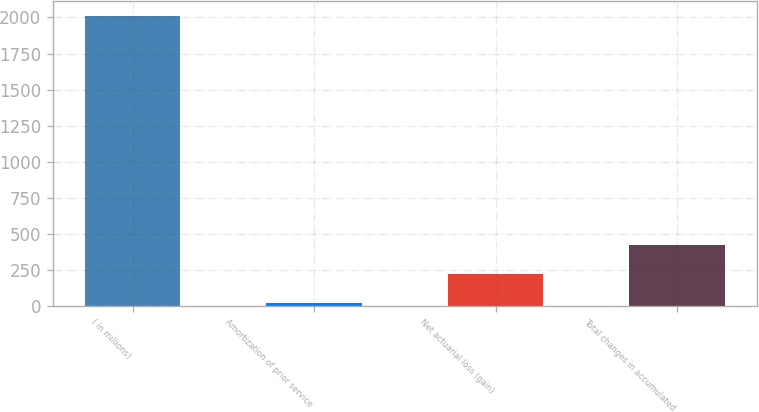Convert chart. <chart><loc_0><loc_0><loc_500><loc_500><bar_chart><fcel>( in millions)<fcel>Amortization of prior service<fcel>Net actuarial loss (gain)<fcel>Total changes in accumulated<nl><fcel>2013<fcel>21<fcel>220.2<fcel>419.4<nl></chart> 